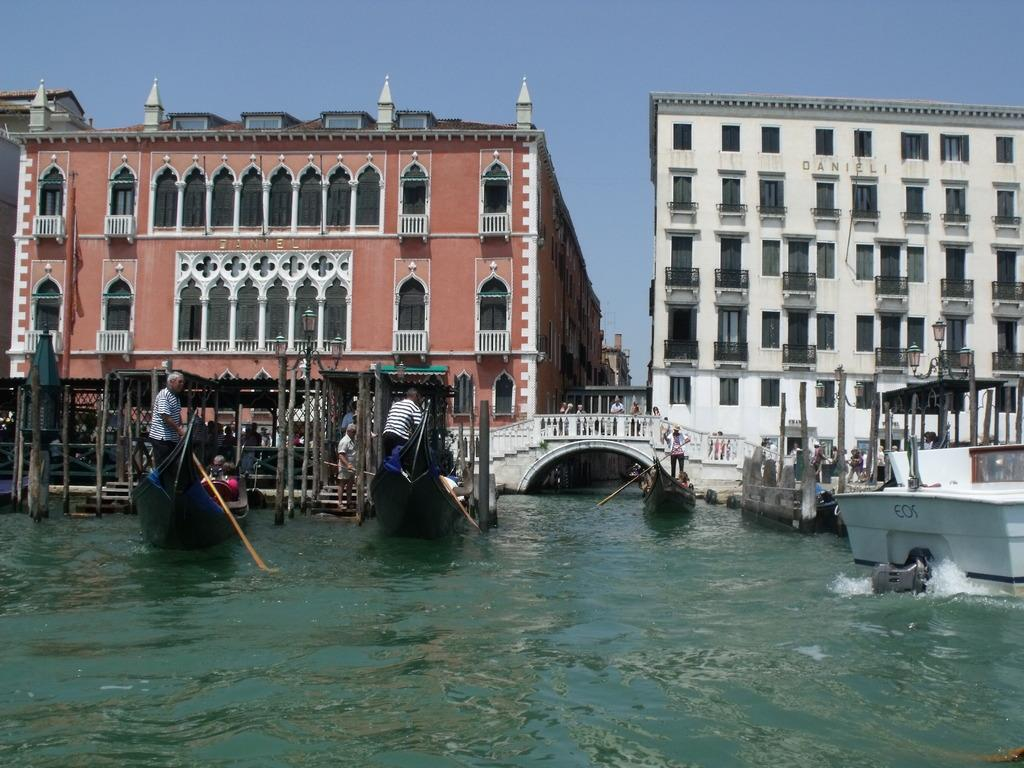What type of structures can be seen in the image? There are buildings in the image. What feature do the buildings have? The buildings have windows. What is the other prominent feature in the image? There is a bridge in the image. What can be seen on the water in the image? There are boats on the water in the image. Are there any people in the boats? Yes, there are people in the boats. What is the color of the sky in the image? The sky is blue in the image. How many times can the people in the boats sort the items in the image? There is no information about sorting items in the image, so this question cannot be answered definitively. What rating would you give the bridge in the image? The provided facts do not include any information about rating the bridge, so this question cannot be answered definitively. 